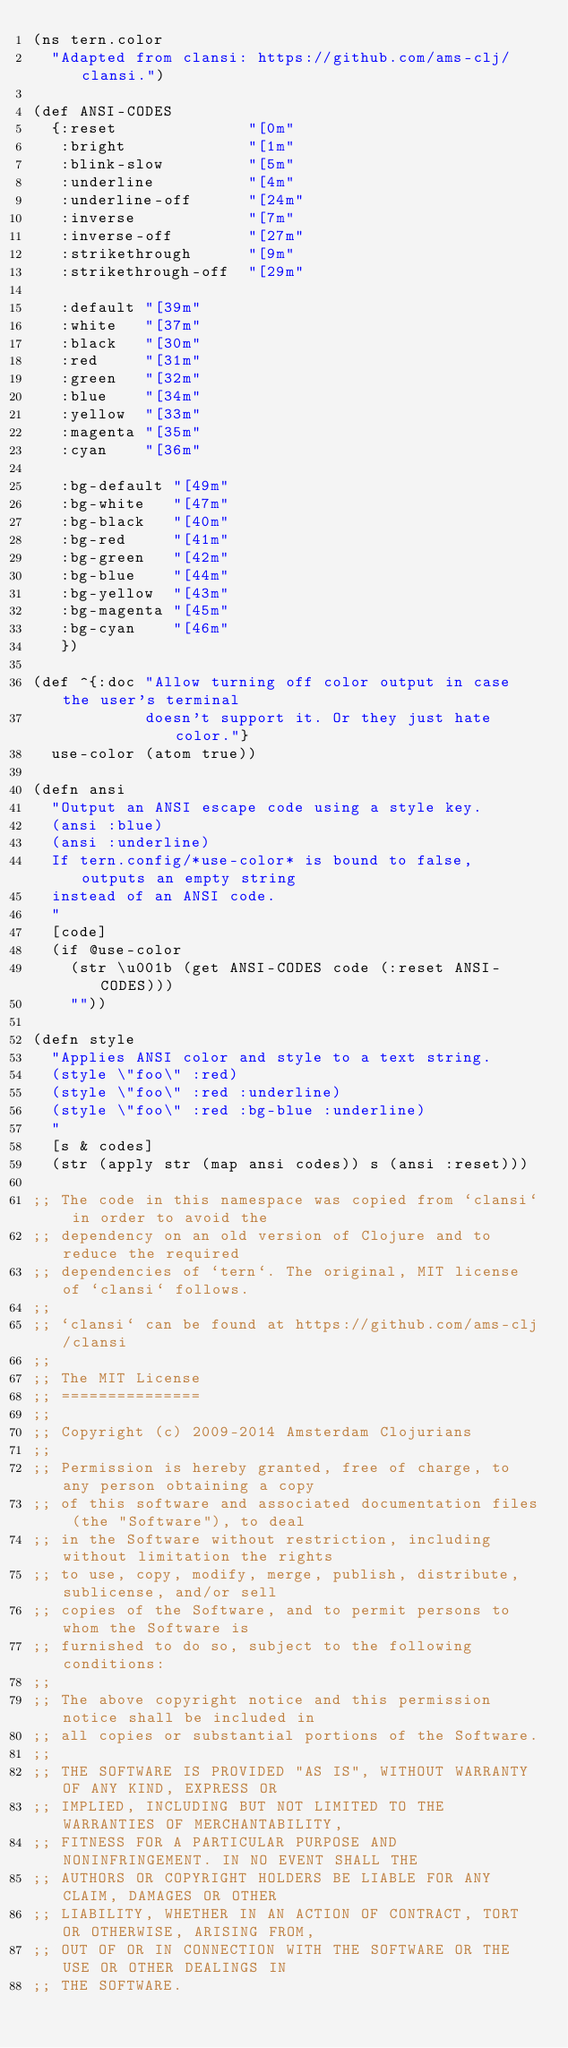Convert code to text. <code><loc_0><loc_0><loc_500><loc_500><_Clojure_>(ns tern.color
  "Adapted from clansi: https://github.com/ams-clj/clansi.")

(def ANSI-CODES
  {:reset              "[0m"
   :bright             "[1m"
   :blink-slow         "[5m"
   :underline          "[4m"
   :underline-off      "[24m"
   :inverse            "[7m"
   :inverse-off        "[27m"
   :strikethrough      "[9m"
   :strikethrough-off  "[29m"

   :default "[39m"
   :white   "[37m"
   :black   "[30m"
   :red     "[31m"
   :green   "[32m"
   :blue    "[34m"
   :yellow  "[33m"
   :magenta "[35m"
   :cyan    "[36m"

   :bg-default "[49m"
   :bg-white   "[47m"
   :bg-black   "[40m"
   :bg-red     "[41m"
   :bg-green   "[42m"
   :bg-blue    "[44m"
   :bg-yellow  "[43m"
   :bg-magenta "[45m"
   :bg-cyan    "[46m"
   })

(def ^{:doc "Allow turning off color output in case the user's terminal
            doesn't support it. Or they just hate color."}
  use-color (atom true))

(defn ansi
  "Output an ANSI escape code using a style key.
  (ansi :blue)
  (ansi :underline)
  If tern.config/*use-color* is bound to false, outputs an empty string
  instead of an ANSI code.
  "
  [code]
  (if @use-color
    (str \u001b (get ANSI-CODES code (:reset ANSI-CODES)))
    ""))

(defn style
  "Applies ANSI color and style to a text string.
  (style \"foo\" :red)
  (style \"foo\" :red :underline)
  (style \"foo\" :red :bg-blue :underline)
  "
  [s & codes]
  (str (apply str (map ansi codes)) s (ansi :reset)))

;; The code in this namespace was copied from `clansi` in order to avoid the
;; dependency on an old version of Clojure and to reduce the required
;; dependencies of `tern`. The original, MIT license of `clansi` follows.
;;
;; `clansi` can be found at https://github.com/ams-clj/clansi
;;
;; The MIT License
;; ===============
;;
;; Copyright (c) 2009-2014 Amsterdam Clojurians
;;
;; Permission is hereby granted, free of charge, to any person obtaining a copy
;; of this software and associated documentation files (the "Software"), to deal
;; in the Software without restriction, including without limitation the rights
;; to use, copy, modify, merge, publish, distribute, sublicense, and/or sell
;; copies of the Software, and to permit persons to whom the Software is
;; furnished to do so, subject to the following conditions:
;;
;; The above copyright notice and this permission notice shall be included in
;; all copies or substantial portions of the Software.
;;
;; THE SOFTWARE IS PROVIDED "AS IS", WITHOUT WARRANTY OF ANY KIND, EXPRESS OR
;; IMPLIED, INCLUDING BUT NOT LIMITED TO THE WARRANTIES OF MERCHANTABILITY,
;; FITNESS FOR A PARTICULAR PURPOSE AND NONINFRINGEMENT. IN NO EVENT SHALL THE
;; AUTHORS OR COPYRIGHT HOLDERS BE LIABLE FOR ANY CLAIM, DAMAGES OR OTHER
;; LIABILITY, WHETHER IN AN ACTION OF CONTRACT, TORT OR OTHERWISE, ARISING FROM,
;; OUT OF OR IN CONNECTION WITH THE SOFTWARE OR THE USE OR OTHER DEALINGS IN
;; THE SOFTWARE.
</code> 